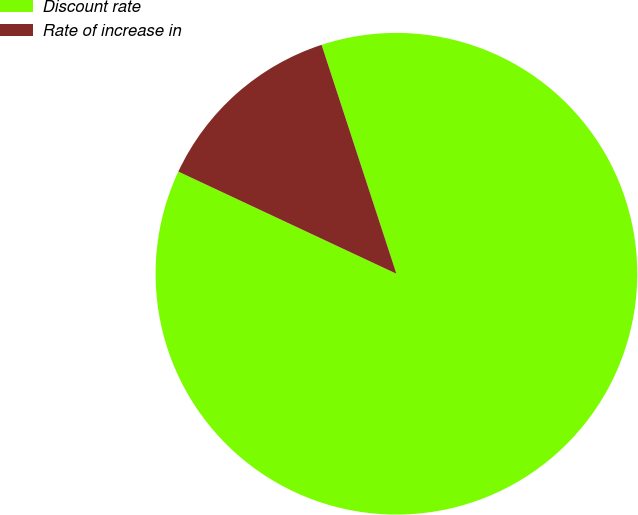Convert chart. <chart><loc_0><loc_0><loc_500><loc_500><pie_chart><fcel>Discount rate<fcel>Rate of increase in<nl><fcel>87.0%<fcel>13.0%<nl></chart> 